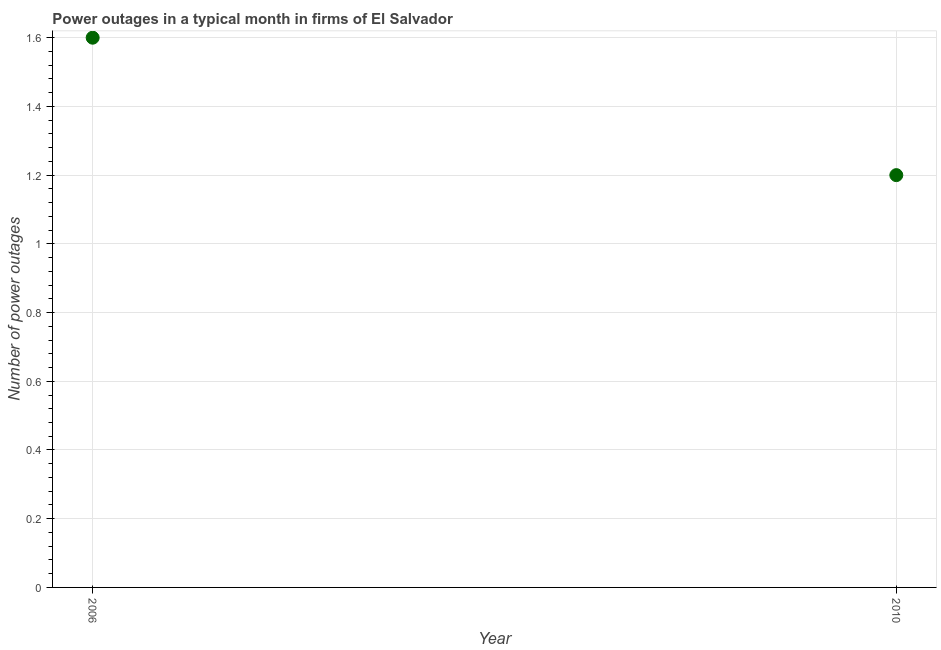Across all years, what is the maximum number of power outages?
Ensure brevity in your answer.  1.6. In which year was the number of power outages minimum?
Ensure brevity in your answer.  2010. What is the sum of the number of power outages?
Provide a short and direct response. 2.8. What is the difference between the number of power outages in 2006 and 2010?
Provide a succinct answer. 0.4. What is the average number of power outages per year?
Your response must be concise. 1.4. What is the ratio of the number of power outages in 2006 to that in 2010?
Your response must be concise. 1.33. Does the number of power outages monotonically increase over the years?
Your response must be concise. No. What is the difference between two consecutive major ticks on the Y-axis?
Provide a succinct answer. 0.2. Are the values on the major ticks of Y-axis written in scientific E-notation?
Make the answer very short. No. What is the title of the graph?
Make the answer very short. Power outages in a typical month in firms of El Salvador. What is the label or title of the Y-axis?
Offer a terse response. Number of power outages. What is the Number of power outages in 2010?
Make the answer very short. 1.2. What is the difference between the Number of power outages in 2006 and 2010?
Provide a short and direct response. 0.4. What is the ratio of the Number of power outages in 2006 to that in 2010?
Make the answer very short. 1.33. 